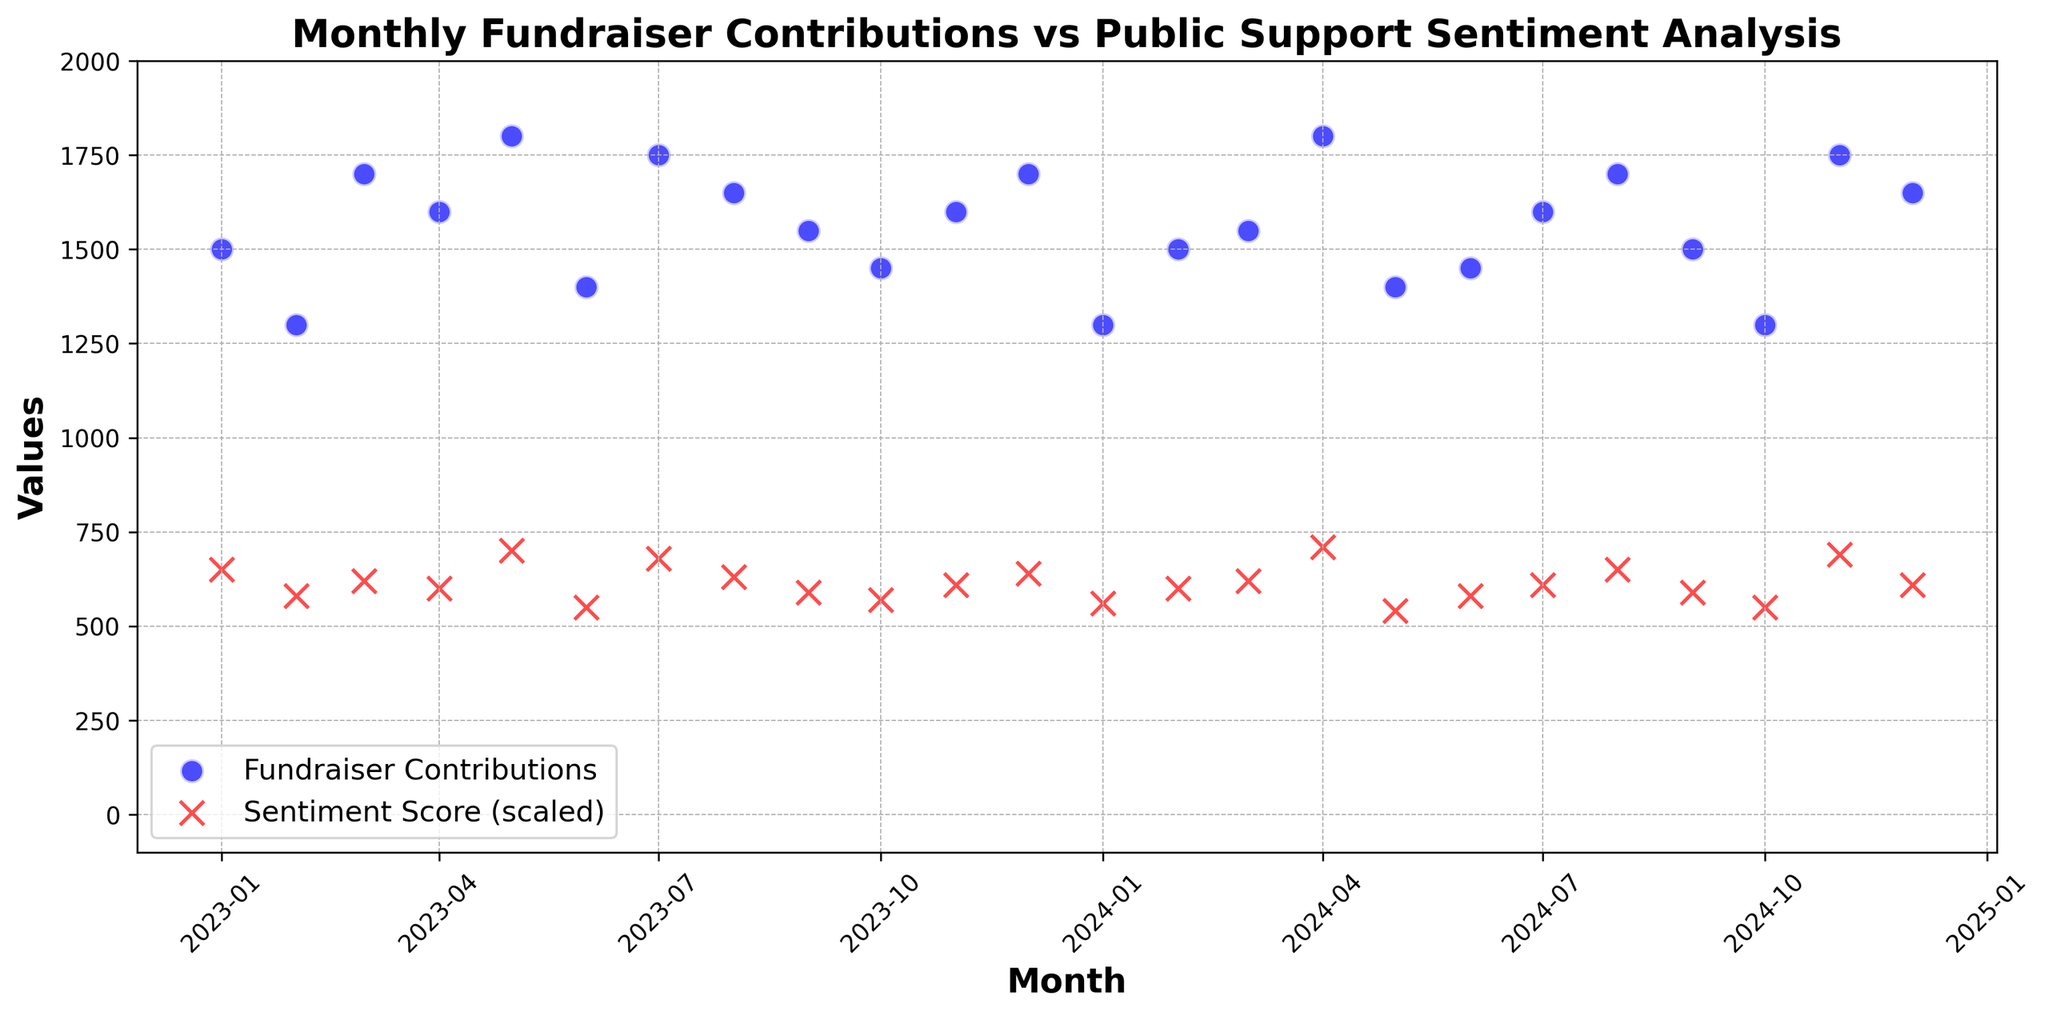What is the trend of Fundraiser Contributions over the two-year period? The scatter plot shows blue dots representing monthly fundraiser contributions over time. Observing the positioning of these dots, we see fluctuations up and down but no clear increasing or decreasing trend overall.
Answer: Fluctuating How does the public sentiment score vary over the months? The red 'x' markers represent the sentiment score (scaled up) over time. The scores seem to fluctuate around a central value without a clear strong trend up or down.
Answer: Fluctuating Which month shows the highest fundraiser contribution, and what is the sentiment score in that month? The highest blue dot is in April 2024, corresponding to a fundraiser contribution of 1800. The red 'x' for April 2024 shows a sentiment score of 0.71.
Answer: April 2024, 0.71 What is the difference between the highest and the lowest Fundraiser Contributions? The highest contribution is 1800 (in May 2023 and April 2024), and the lowest contribution is 1300 (in February 2023, January 2024, October 2024). The difference is 1800 - 1300 = 500.
Answer: 500 In which month was the sentiment score the lowest, and what were the fundraiser contributions for that month? The lowest sentiment score is 0.54, observed in May 2024. The corresponding fundraiser contribution in May 2024 is 1400.
Answer: May 2024, 1400 How do the contributions in December 2023 compare to those in December 2024? The blue dots for December 2023 and 2024 show contributions of 1700 and 1650, respectively.
Answer: Higher in December 2023 What is the average Fundraiser Contribution over the two-year period? Sum of all monthly contributions is 38850. There are 24 months, so the average is 38850 / 24 = 1618.75.
Answer: 1618.75 Identify the months when both Fundraiser Contributions and Sentiment scores show a peak. Peaks can be visually identified when blue dots and red 'x's are both at high points. These months include May 2023 and April 2024 (with contributions of 1800 and sentiment scores of 0.70 and 0.71 respectively).
Answer: May 2023, April 2024 Are there any months where the sentiment score is positive, but fundraiser contributions are relatively low (below 1500)? By examining the red 'x's above the average sentiment score line (around 0.6) and blue dots below 1500, the months meeting this condition are January 2023, February 2023, January 2024, May 2024, October 2024.
Answer: January 2023, February 2023, January 2024, May 2024, October 2024 What is the relationship between high fundraiser contributions and high sentiment scores? By viewing the scatter plot, high fundraiser contributions (around 1800) usually coincide with relatively higher sentiment scores (above 0.60), suggesting a positive correlation.
Answer: Positive correlation 